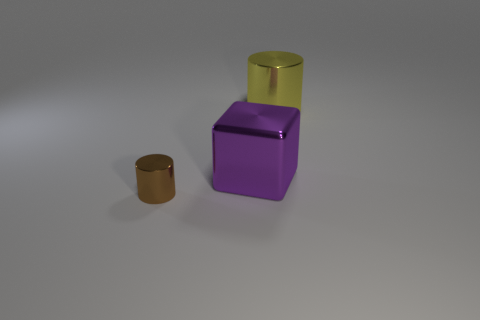Add 2 tiny yellow metal cubes. How many objects exist? 5 Subtract all blocks. How many objects are left? 2 Subtract 0 gray balls. How many objects are left? 3 Subtract all blue metal objects. Subtract all tiny brown objects. How many objects are left? 2 Add 2 small cylinders. How many small cylinders are left? 3 Add 3 big red shiny blocks. How many big red shiny blocks exist? 3 